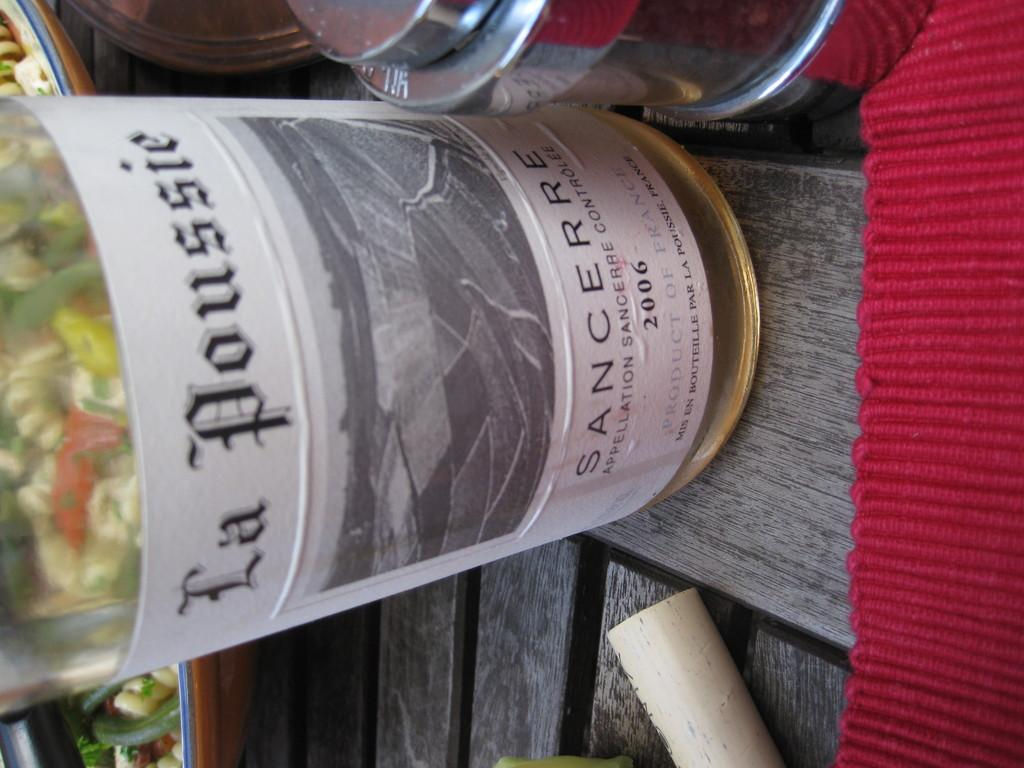What type of furniture is present in the image? There is a table in the image. What is on top of the table? There is a red color mat, a bottle, and boxes on the table. Is there a wound visible on the table in the image? No, there is no wound present in the image. What type of performance might be happening on the stage in the image? There is no stage present in the image. 